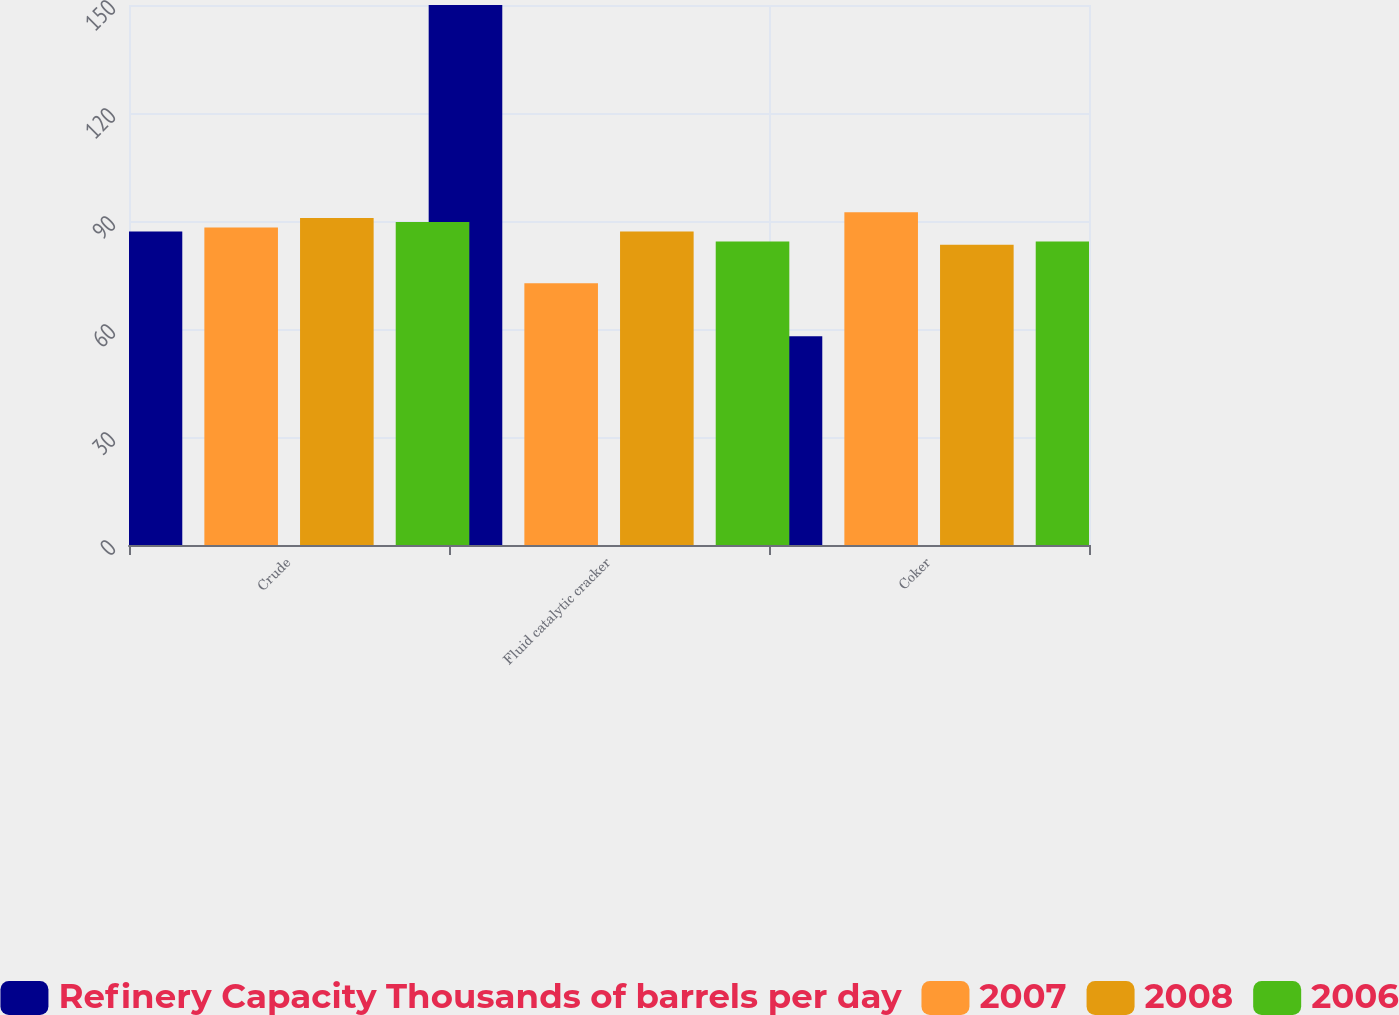Convert chart to OTSL. <chart><loc_0><loc_0><loc_500><loc_500><stacked_bar_chart><ecel><fcel>Crude<fcel>Fluid catalytic cracker<fcel>Coker<nl><fcel>Refinery Capacity Thousands of barrels per day<fcel>87.1<fcel>150<fcel>58<nl><fcel>2007<fcel>88.2<fcel>72.7<fcel>92.4<nl><fcel>2008<fcel>90.8<fcel>87.1<fcel>83.4<nl><fcel>2006<fcel>89.7<fcel>84.3<fcel>84.3<nl></chart> 